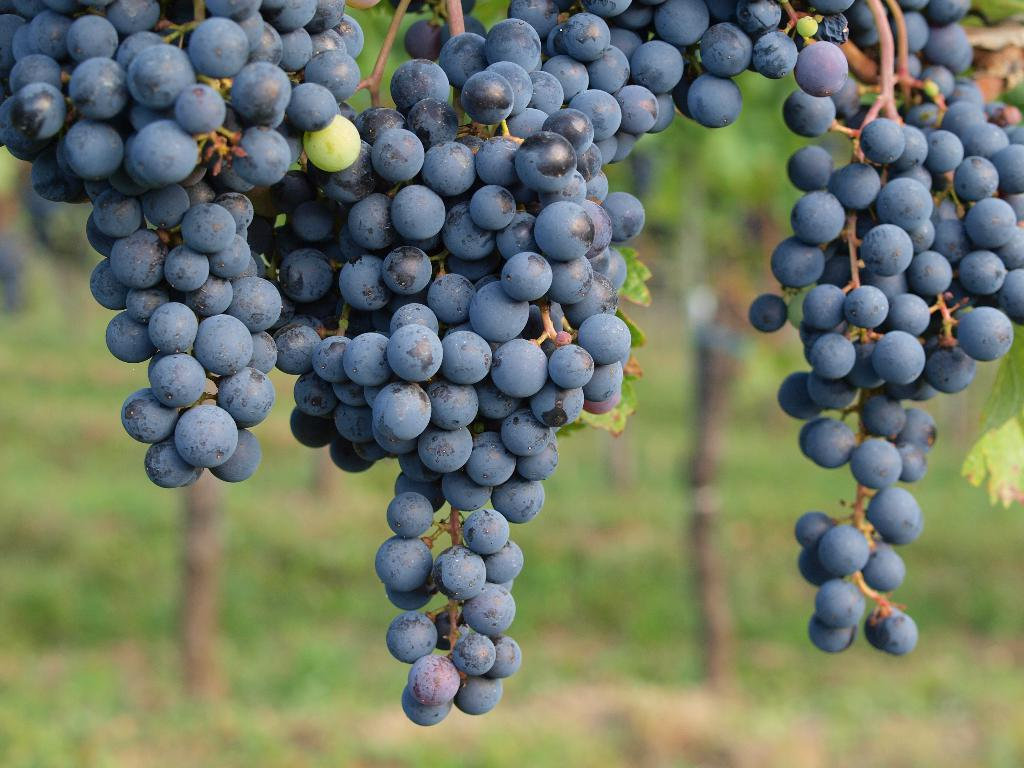What is the main subject of the image? The main subject of the image is grapes. Where are the grapes located in the image? The grapes are in the middle of the image. What can be seen in the background of the image? There are plants in the background of the image. What is the color of the grapes? The grapes are black in color. What type of songs can be heard coming from the grapes in the image? There are no songs coming from the grapes in the image, as grapes do not produce sound. 